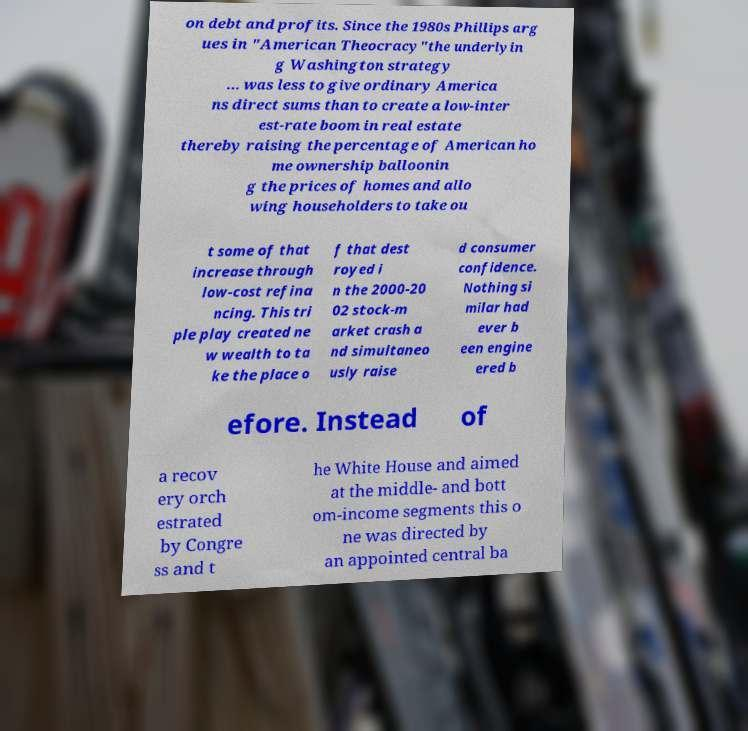Could you extract and type out the text from this image? on debt and profits. Since the 1980s Phillips arg ues in "American Theocracy"the underlyin g Washington strategy … was less to give ordinary America ns direct sums than to create a low-inter est-rate boom in real estate thereby raising the percentage of American ho me ownership balloonin g the prices of homes and allo wing householders to take ou t some of that increase through low-cost refina ncing. This tri ple play created ne w wealth to ta ke the place o f that dest royed i n the 2000-20 02 stock-m arket crash a nd simultaneo usly raise d consumer confidence. Nothing si milar had ever b een engine ered b efore. Instead of a recov ery orch estrated by Congre ss and t he White House and aimed at the middle- and bott om-income segments this o ne was directed by an appointed central ba 